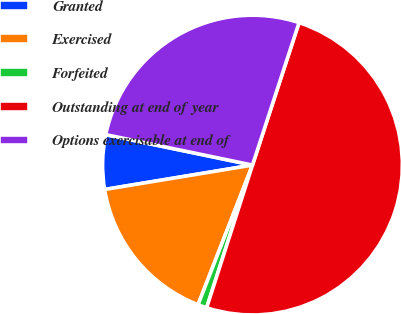<chart> <loc_0><loc_0><loc_500><loc_500><pie_chart><fcel>Granted<fcel>Exercised<fcel>Forfeited<fcel>Outstanding at end of year<fcel>Options exercisable at end of<nl><fcel>5.86%<fcel>16.48%<fcel>0.97%<fcel>49.92%<fcel>26.77%<nl></chart> 